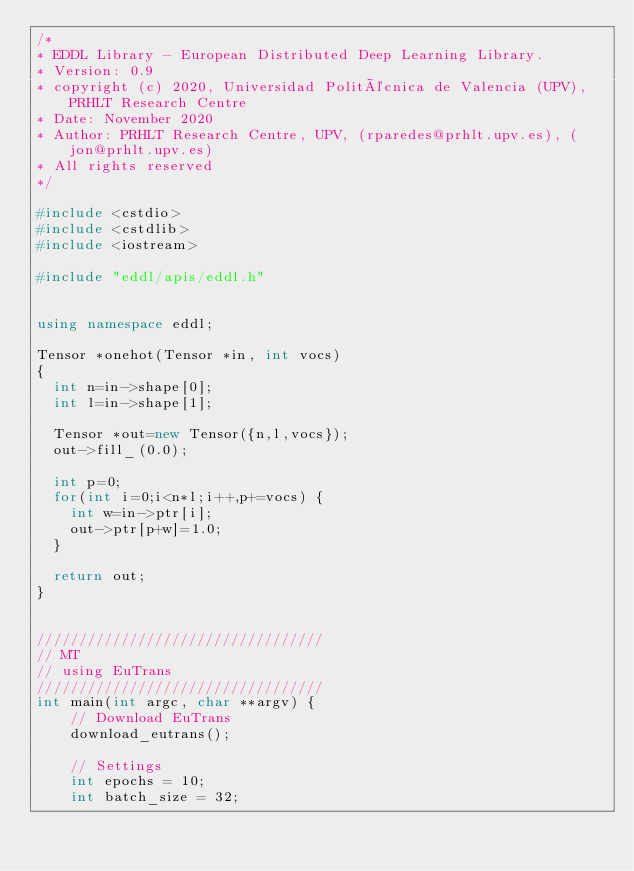Convert code to text. <code><loc_0><loc_0><loc_500><loc_500><_C++_>/*
* EDDL Library - European Distributed Deep Learning Library.
* Version: 0.9
* copyright (c) 2020, Universidad Politécnica de Valencia (UPV), PRHLT Research Centre
* Date: November 2020
* Author: PRHLT Research Centre, UPV, (rparedes@prhlt.upv.es), (jon@prhlt.upv.es)
* All rights reserved
*/

#include <cstdio>
#include <cstdlib>
#include <iostream>

#include "eddl/apis/eddl.h"


using namespace eddl;

Tensor *onehot(Tensor *in, int vocs)
{
  int n=in->shape[0];
  int l=in->shape[1];

  Tensor *out=new Tensor({n,l,vocs});
  out->fill_(0.0);

  int p=0;
  for(int i=0;i<n*l;i++,p+=vocs) {
    int w=in->ptr[i];
    out->ptr[p+w]=1.0;
  }

  return out;
}


//////////////////////////////////
// MT
// using EuTrans
//////////////////////////////////
int main(int argc, char **argv) {
    // Download EuTrans
    download_eutrans();

    // Settings
    int epochs = 10;
    int batch_size = 32;
</code> 